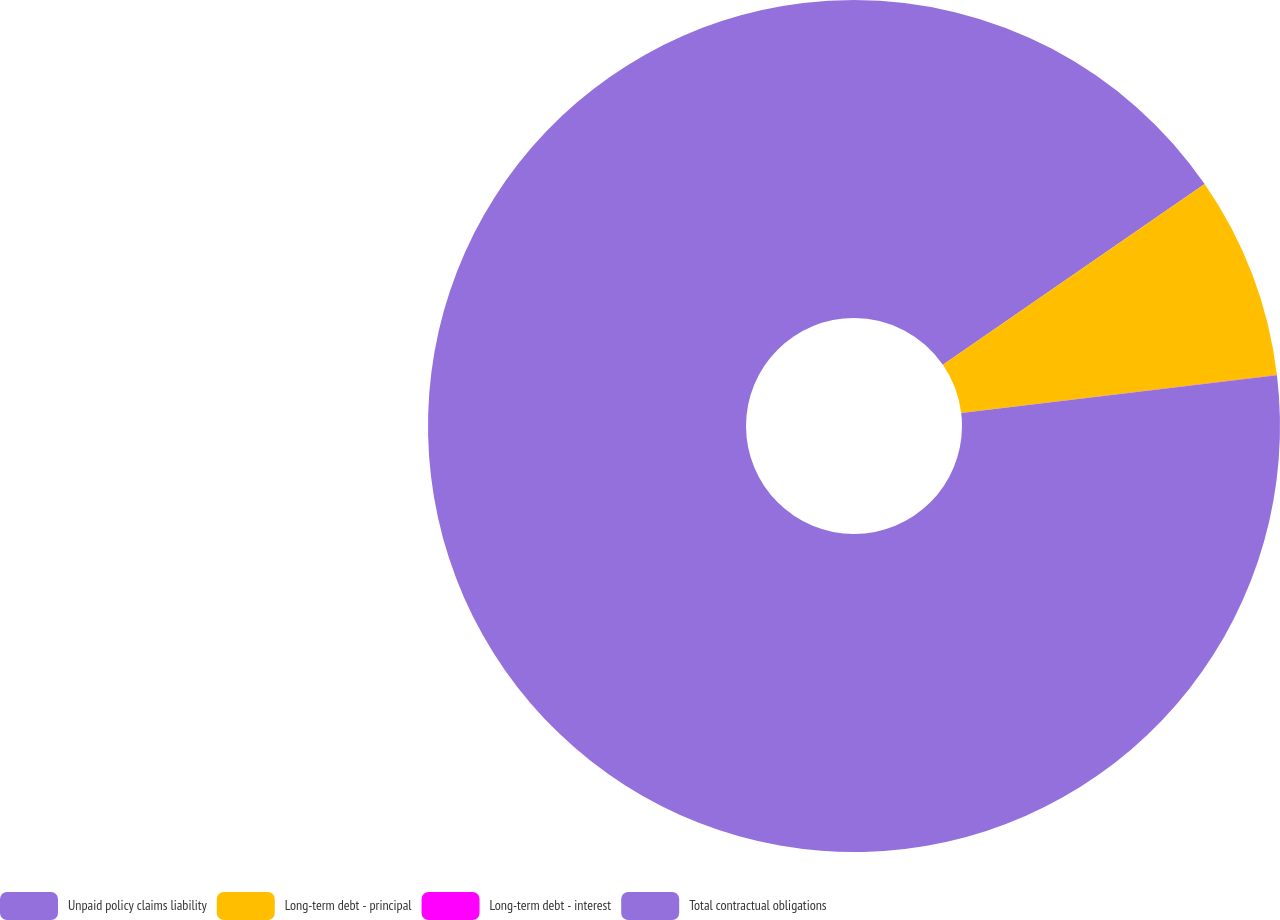Convert chart to OTSL. <chart><loc_0><loc_0><loc_500><loc_500><pie_chart><fcel>Unpaid policy claims liability<fcel>Long-term debt - principal<fcel>Long-term debt - interest<fcel>Total contractual obligations<nl><fcel>15.39%<fcel>7.7%<fcel>0.01%<fcel>76.91%<nl></chart> 